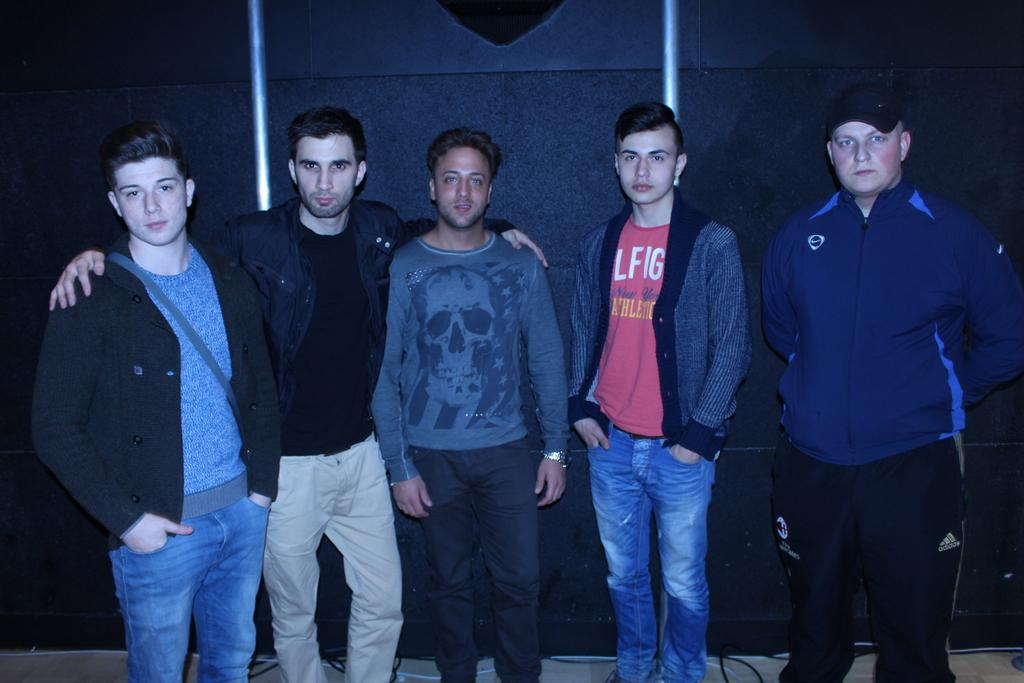How many people are in the image? There are five men in the image. What are the men doing in the image? The men are standing in the image. Are the men looking at something or someone? Yes, the men are looking at someone. What time of day is it in the image, and is there a stream nearby? The provided facts do not mention the time of day or the presence of a stream, so we cannot determine that information from the image. 